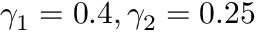Convert formula to latex. <formula><loc_0><loc_0><loc_500><loc_500>\gamma _ { 1 } = 0 . 4 , \gamma _ { 2 } = 0 . 2 5</formula> 